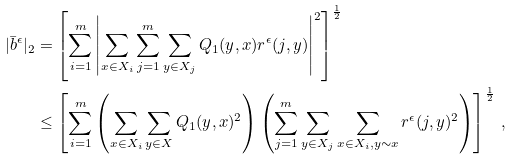<formula> <loc_0><loc_0><loc_500><loc_500>| \bar { b } ^ { \epsilon } | _ { 2 } & = \left [ \sum _ { i = 1 } ^ { m } \left | \sum _ { x \in X _ { i } } \sum _ { j = 1 } ^ { m } \sum _ { y \in X _ { j } } Q _ { 1 } ( y , x ) r ^ { \epsilon } ( j , y ) \right | ^ { 2 } \right ] ^ { \frac { 1 } { 2 } } \\ & \leq \left [ \sum _ { i = 1 } ^ { m } \left ( \sum _ { x \in X _ { i } } \sum _ { y \in X } Q _ { 1 } ( y , x ) ^ { 2 } \right ) \left ( \sum _ { j = 1 } ^ { m } \sum _ { y \in X _ { j } } \sum _ { x \in X _ { i } , y \sim x } r ^ { \epsilon } ( j , y ) ^ { 2 } \right ) \right ] ^ { \frac { 1 } { 2 } } \, ,</formula> 